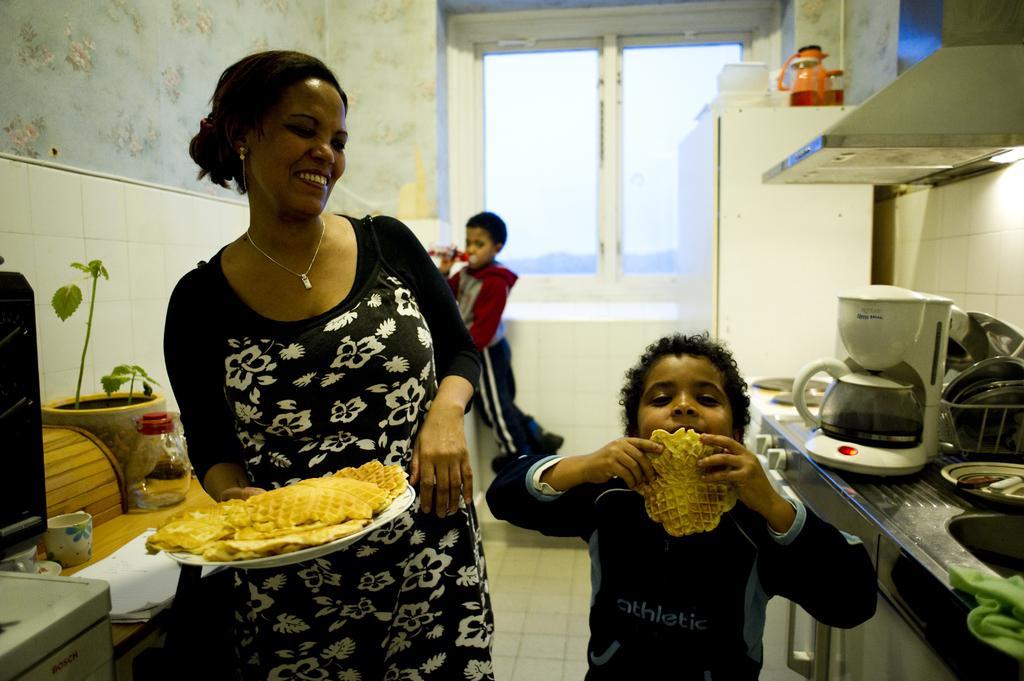Describe this image in one or two sentences. This picture is clicked inside. On the left there is a woman wearing black color dress, holding a plate of food and standing. On the right there is a kid holding a food item and standing. On the right corner we can see there are some objects placed on the top of the stove and there is a white color cabinet on the top of which many number of items are placed. On the left corner we can see the kitchen platform on the top of which a cup, glass jar, house plant and some other items are placed. In the background we can see the wall, window and a person holding some object and standing on the ground. In the top right corner we can see the chimney. 